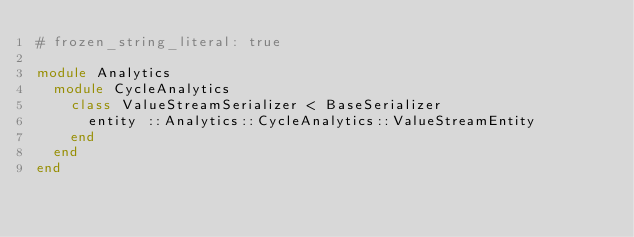<code> <loc_0><loc_0><loc_500><loc_500><_Ruby_># frozen_string_literal: true

module Analytics
  module CycleAnalytics
    class ValueStreamSerializer < BaseSerializer
      entity ::Analytics::CycleAnalytics::ValueStreamEntity
    end
  end
end
</code> 